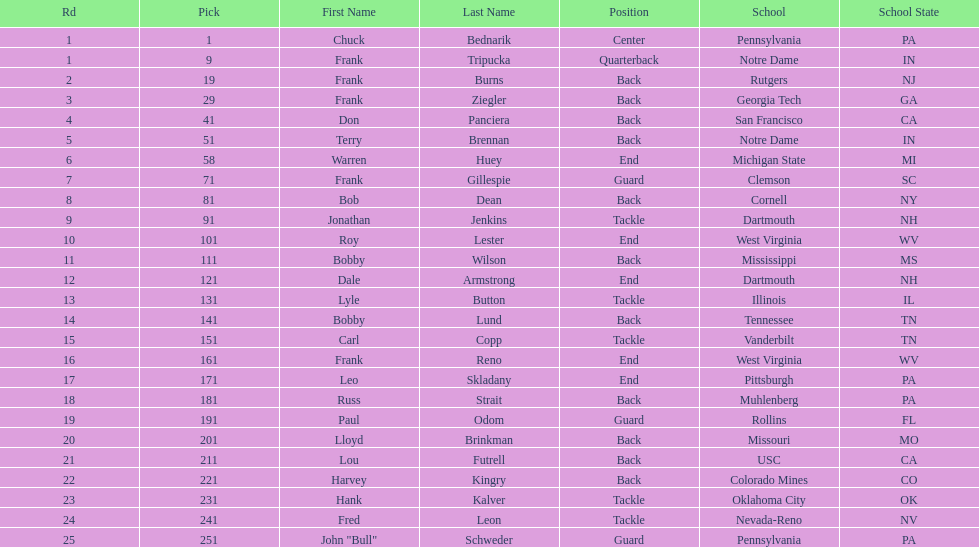Who was picked after roy lester? Bobby Wilson. Could you parse the entire table? {'header': ['Rd', 'Pick', 'First Name', 'Last Name', 'Position', 'School', 'School State'], 'rows': [['1', '1', 'Chuck', 'Bednarik', 'Center', 'Pennsylvania', 'PA'], ['1', '9', 'Frank', 'Tripucka', 'Quarterback', 'Notre Dame', 'IN'], ['2', '19', 'Frank', 'Burns', 'Back', 'Rutgers', 'NJ'], ['3', '29', 'Frank', 'Ziegler', 'Back', 'Georgia Tech', 'GA'], ['4', '41', 'Don', 'Panciera', 'Back', 'San Francisco', 'CA'], ['5', '51', 'Terry', 'Brennan', 'Back', 'Notre Dame', 'IN'], ['6', '58', 'Warren', 'Huey', 'End', 'Michigan State', 'MI'], ['7', '71', 'Frank', 'Gillespie', 'Guard', 'Clemson', 'SC'], ['8', '81', 'Bob', 'Dean', 'Back', 'Cornell', 'NY'], ['9', '91', 'Jonathan', 'Jenkins', 'Tackle', 'Dartmouth', 'NH'], ['10', '101', 'Roy', 'Lester', 'End', 'West Virginia', 'WV'], ['11', '111', 'Bobby', 'Wilson', 'Back', 'Mississippi', 'MS'], ['12', '121', 'Dale', 'Armstrong', 'End', 'Dartmouth', 'NH'], ['13', '131', 'Lyle', 'Button', 'Tackle', 'Illinois', 'IL'], ['14', '141', 'Bobby', 'Lund', 'Back', 'Tennessee', 'TN'], ['15', '151', 'Carl', 'Copp', 'Tackle', 'Vanderbilt', 'TN'], ['16', '161', 'Frank', 'Reno', 'End', 'West Virginia', 'WV'], ['17', '171', 'Leo', 'Skladany', 'End', 'Pittsburgh', 'PA'], ['18', '181', 'Russ', 'Strait', 'Back', 'Muhlenberg', 'PA'], ['19', '191', 'Paul', 'Odom', 'Guard', 'Rollins', 'FL'], ['20', '201', 'Lloyd', 'Brinkman', 'Back', 'Missouri', 'MO'], ['21', '211', 'Lou', 'Futrell', 'Back', 'USC', 'CA'], ['22', '221', 'Harvey', 'Kingry', 'Back', 'Colorado Mines', 'CO'], ['23', '231', 'Hank', 'Kalver', 'Tackle', 'Oklahoma City', 'OK'], ['24', '241', 'Fred', 'Leon', 'Tackle', 'Nevada-Reno', 'NV'], ['25', '251', 'John "Bull"', 'Schweder', 'Guard', 'Pennsylvania', 'PA']]} 